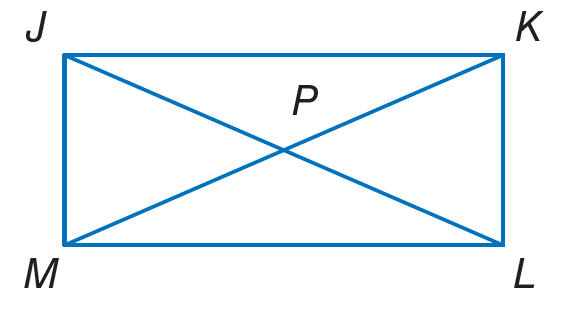Question: Quadrilateral J K L M is a rectangle. If m \angle K J L = 2 x + 4 and m \angle J L K = 7 x + 5, find x.
Choices:
A. 9
B. 22
C. 45
D. 68
Answer with the letter. Answer: A 